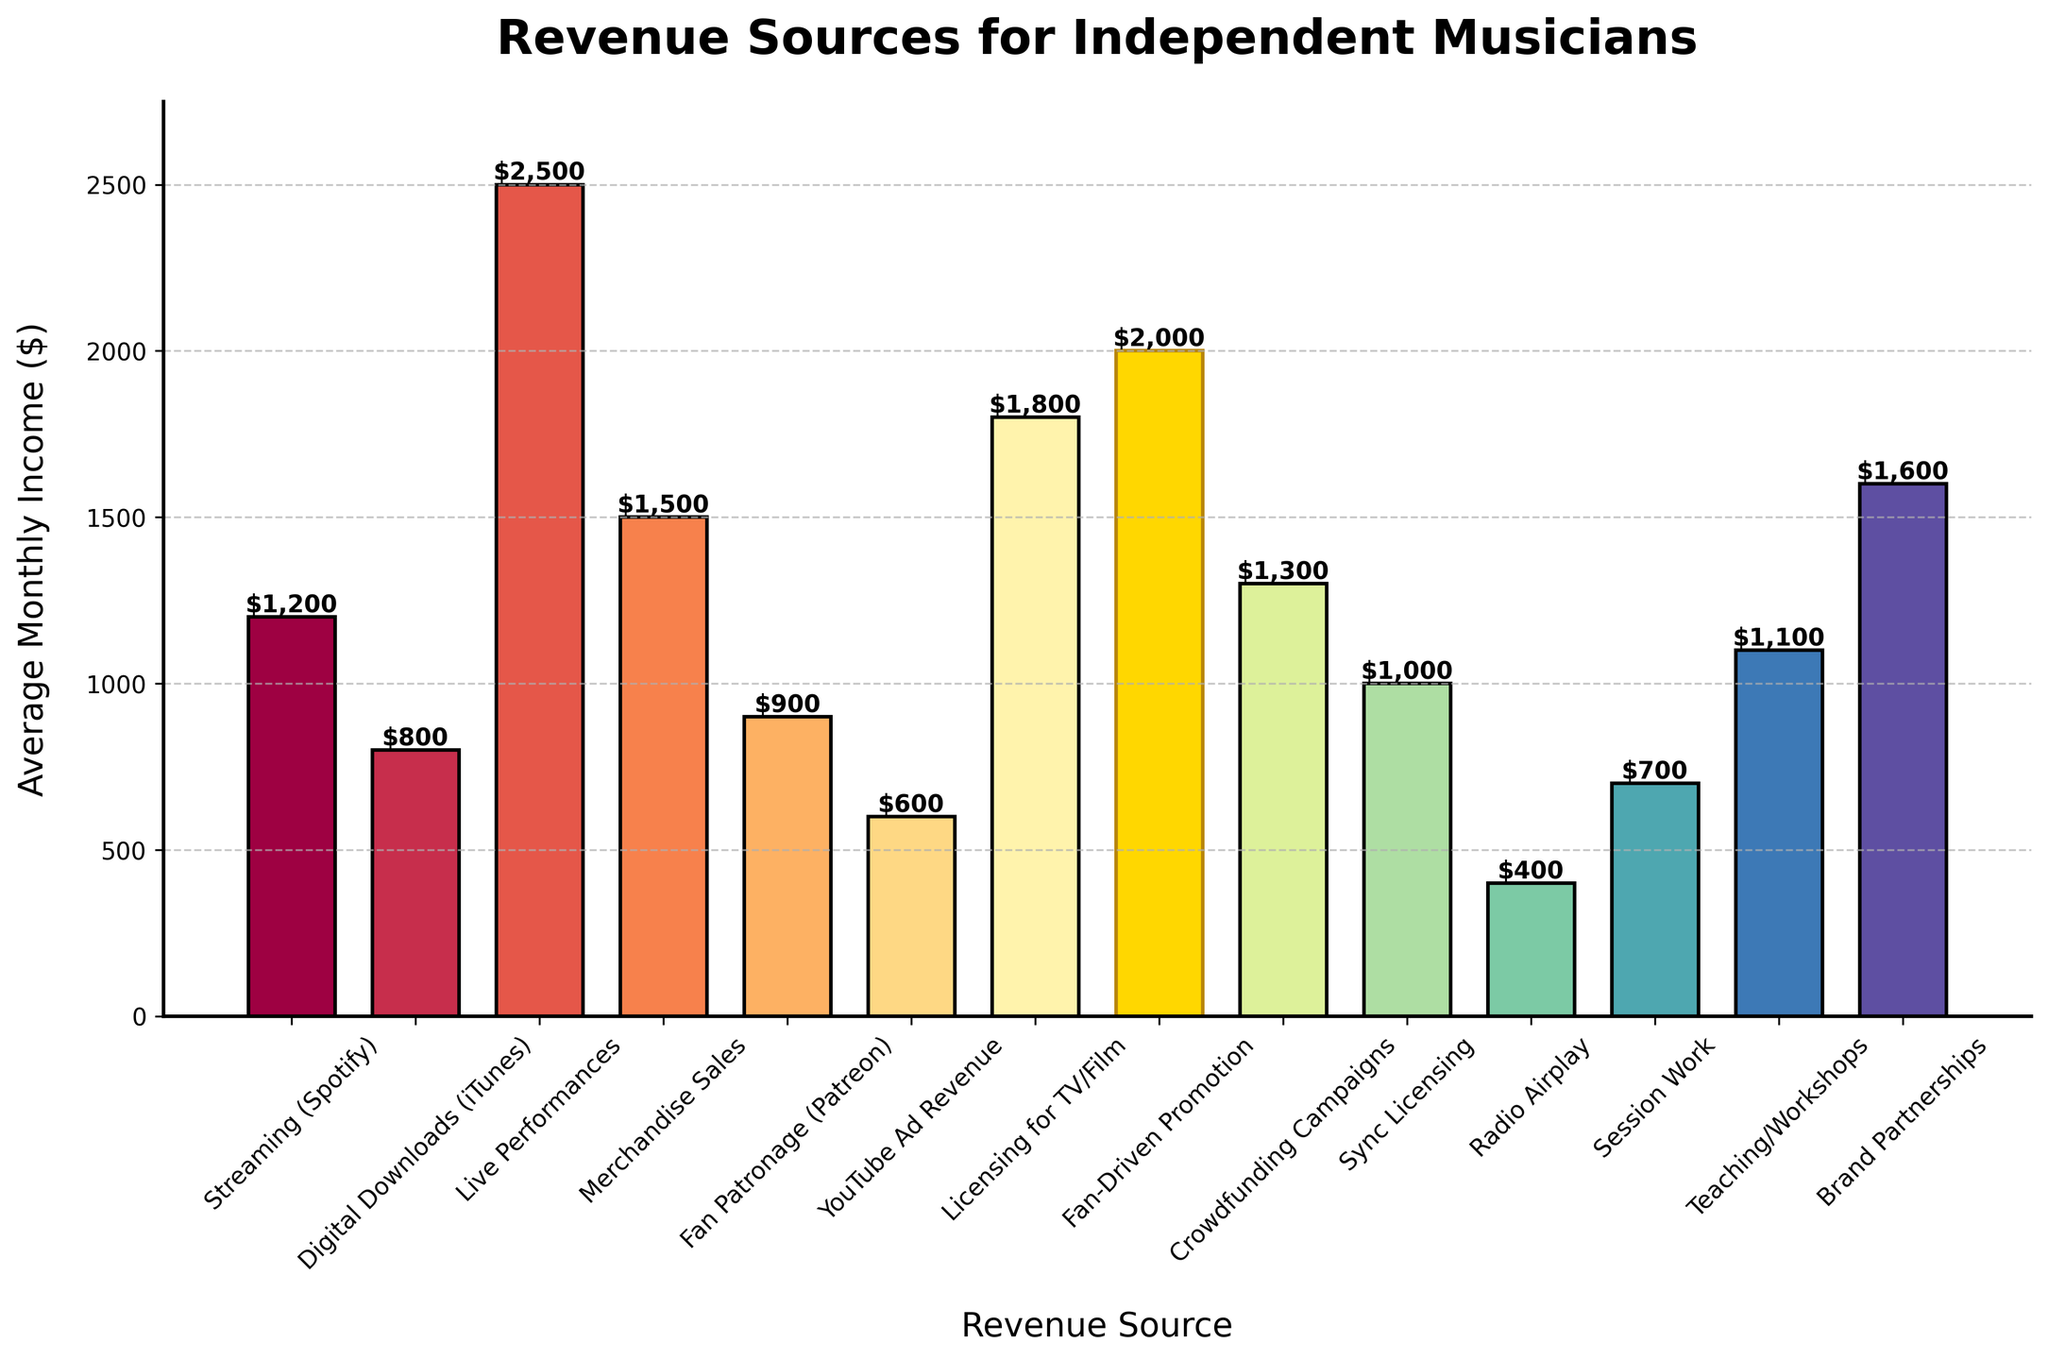Which revenue source is highlighted with a different color? The bar for "Fan-Driven Promotion" is highlighted with a gold color, indicating its importance or special focus in the chart.
Answer: Fan-Driven Promotion What is the highest average monthly income source? By looking at the heights of the bars, the tallest bar corresponds to "Live Performances".
Answer: Live Performances What is the combined average monthly income from Streaming (Spotify) and YouTube Ad Revenue? The average monthly income from Streaming (Spotify) is $1200 and from YouTube Ad Revenue is $600. Adding them gives $1200 + $600 = $1800.
Answer: $1800 How much more does Merchandise Sales generate compared to Radio Airplay? Merchandise Sales generates $1500, and Radio Airplay generates $400. The difference is $1500 - $400 = $1100.
Answer: $1100 What is the average monthly income for revenue sources highlighted by fan-driven activities (Fan-Driven Promotion and Fan Patronage)? Fan-Driven Promotion generates $2000, and Fan Patronage generates $900. The average is ($2000 + $900) / 2 = $1450.
Answer: $1450 Which revenue source generates more income: Crowdfunding Campaigns or Teaching/Workshops? Comparing the heights of the bars, Crowdfunding Campaigns generate $1300, while Teaching/Workshops generate $1100. Crowdfunding Campaigns generate more income.
Answer: Crowdfunding Campaigns Which revenue sources generate an average monthly income greater than $1000 but less than $2000? By examining the heights and values of the bars, Licencing for TV/Film ($1800), Sync Licensing ($1000), Teaching/Workshops ($1100), and Crowdfunding Campaigns ($1300) fit this range.
Answer: Licensing for TV/Film, Sync Licensing, Teaching/Workshops, Crowdfunding Campaigns What is the total average monthly income from the top three revenue sources? The top three revenue sources are "Live Performances" ($2500), "Fan-Driven Promotion" ($2000), and "Licensing for TV/Film" ($1800). Summing them up gives $2500 + $2000 + $1800 = $6300.
Answer: $6300 